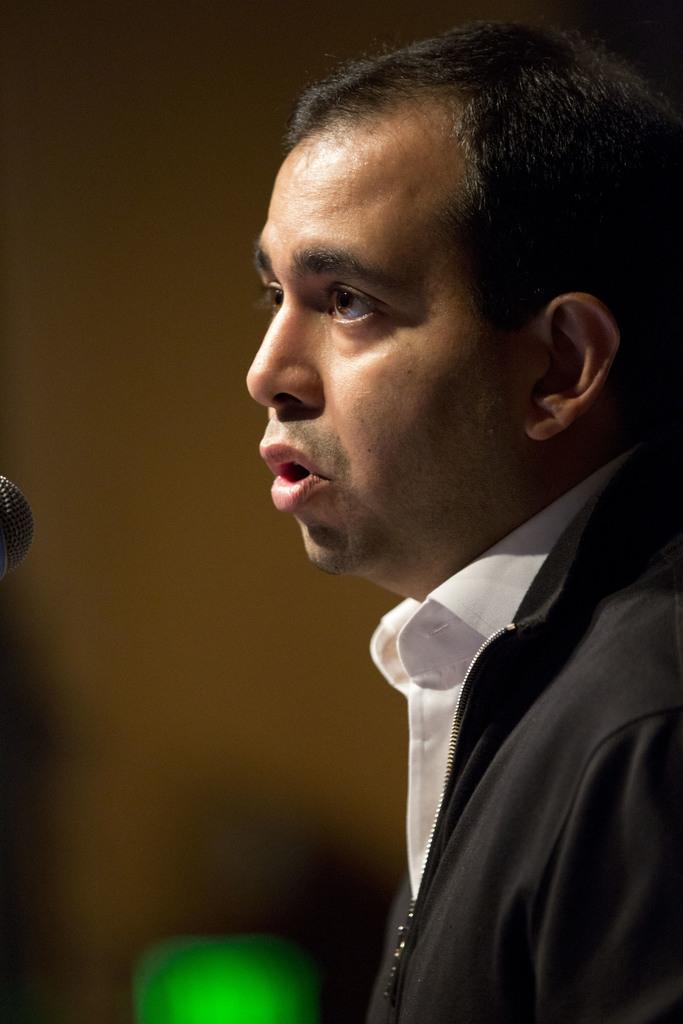In one or two sentences, can you explain what this image depicts? In this picture we can see a man, he wore a black color jacket and white color shirt. 